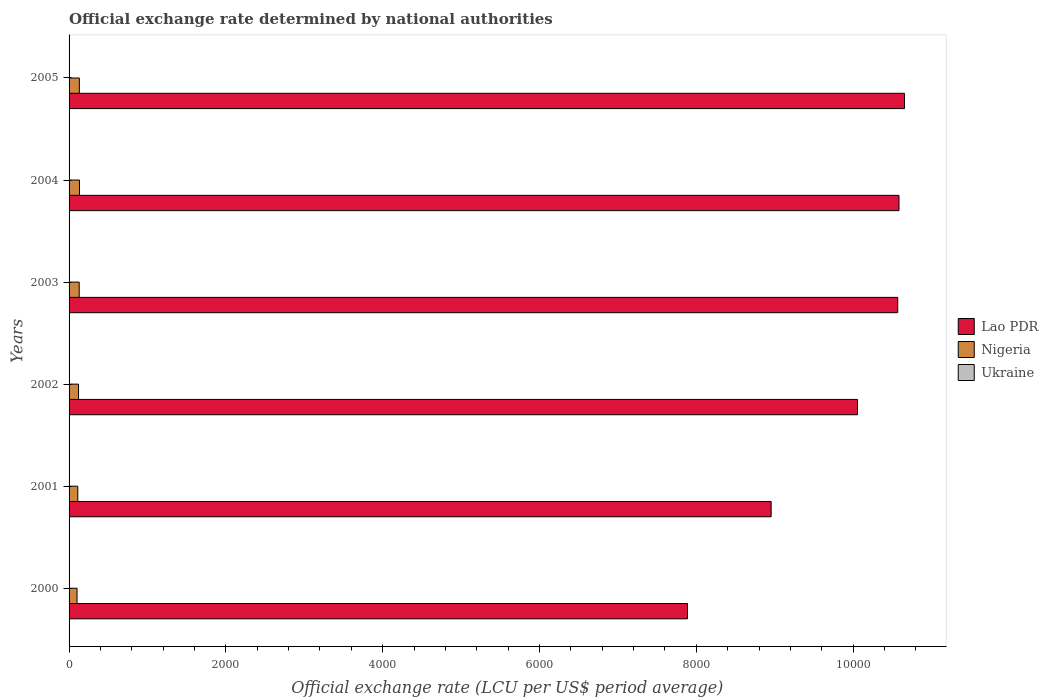How many different coloured bars are there?
Provide a succinct answer. 3. How many groups of bars are there?
Provide a short and direct response. 6. In how many cases, is the number of bars for a given year not equal to the number of legend labels?
Offer a very short reply. 0. What is the official exchange rate in Nigeria in 2001?
Your response must be concise. 111.23. Across all years, what is the maximum official exchange rate in Nigeria?
Offer a terse response. 132.89. Across all years, what is the minimum official exchange rate in Lao PDR?
Give a very brief answer. 7887.64. In which year was the official exchange rate in Lao PDR minimum?
Make the answer very short. 2000. What is the total official exchange rate in Lao PDR in the graph?
Provide a short and direct response. 5.87e+04. What is the difference between the official exchange rate in Lao PDR in 2001 and that in 2003?
Make the answer very short. -1614.45. What is the difference between the official exchange rate in Lao PDR in 2000 and the official exchange rate in Nigeria in 2001?
Offer a terse response. 7776.41. What is the average official exchange rate in Nigeria per year?
Offer a very short reply. 121.15. In the year 2004, what is the difference between the official exchange rate in Nigeria and official exchange rate in Ukraine?
Provide a short and direct response. 127.57. In how many years, is the official exchange rate in Lao PDR greater than 2800 LCU?
Ensure brevity in your answer.  6. What is the ratio of the official exchange rate in Nigeria in 2001 to that in 2003?
Ensure brevity in your answer.  0.86. Is the official exchange rate in Lao PDR in 2000 less than that in 2005?
Your answer should be compact. Yes. What is the difference between the highest and the second highest official exchange rate in Ukraine?
Keep it short and to the point. 0.07. What is the difference between the highest and the lowest official exchange rate in Nigeria?
Offer a very short reply. 31.19. In how many years, is the official exchange rate in Ukraine greater than the average official exchange rate in Ukraine taken over all years?
Provide a short and direct response. 4. What does the 2nd bar from the top in 2001 represents?
Keep it short and to the point. Nigeria. What does the 3rd bar from the bottom in 2000 represents?
Your response must be concise. Ukraine. Is it the case that in every year, the sum of the official exchange rate in Ukraine and official exchange rate in Nigeria is greater than the official exchange rate in Lao PDR?
Keep it short and to the point. No. What is the difference between two consecutive major ticks on the X-axis?
Your answer should be very brief. 2000. Where does the legend appear in the graph?
Make the answer very short. Center right. How many legend labels are there?
Keep it short and to the point. 3. What is the title of the graph?
Provide a short and direct response. Official exchange rate determined by national authorities. What is the label or title of the X-axis?
Your response must be concise. Official exchange rate (LCU per US$ period average). What is the label or title of the Y-axis?
Keep it short and to the point. Years. What is the Official exchange rate (LCU per US$ period average) of Lao PDR in 2000?
Your answer should be very brief. 7887.64. What is the Official exchange rate (LCU per US$ period average) of Nigeria in 2000?
Keep it short and to the point. 101.7. What is the Official exchange rate (LCU per US$ period average) of Ukraine in 2000?
Provide a short and direct response. 5.44. What is the Official exchange rate (LCU per US$ period average) of Lao PDR in 2001?
Keep it short and to the point. 8954.58. What is the Official exchange rate (LCU per US$ period average) of Nigeria in 2001?
Offer a very short reply. 111.23. What is the Official exchange rate (LCU per US$ period average) of Ukraine in 2001?
Provide a succinct answer. 5.37. What is the Official exchange rate (LCU per US$ period average) of Lao PDR in 2002?
Make the answer very short. 1.01e+04. What is the Official exchange rate (LCU per US$ period average) of Nigeria in 2002?
Offer a terse response. 120.58. What is the Official exchange rate (LCU per US$ period average) in Ukraine in 2002?
Provide a succinct answer. 5.33. What is the Official exchange rate (LCU per US$ period average) of Lao PDR in 2003?
Your answer should be compact. 1.06e+04. What is the Official exchange rate (LCU per US$ period average) in Nigeria in 2003?
Provide a short and direct response. 129.22. What is the Official exchange rate (LCU per US$ period average) of Ukraine in 2003?
Offer a terse response. 5.33. What is the Official exchange rate (LCU per US$ period average) in Lao PDR in 2004?
Keep it short and to the point. 1.06e+04. What is the Official exchange rate (LCU per US$ period average) of Nigeria in 2004?
Give a very brief answer. 132.89. What is the Official exchange rate (LCU per US$ period average) of Ukraine in 2004?
Provide a short and direct response. 5.32. What is the Official exchange rate (LCU per US$ period average) of Lao PDR in 2005?
Your answer should be compact. 1.07e+04. What is the Official exchange rate (LCU per US$ period average) in Nigeria in 2005?
Ensure brevity in your answer.  131.27. What is the Official exchange rate (LCU per US$ period average) of Ukraine in 2005?
Your answer should be compact. 5.12. Across all years, what is the maximum Official exchange rate (LCU per US$ period average) of Lao PDR?
Your response must be concise. 1.07e+04. Across all years, what is the maximum Official exchange rate (LCU per US$ period average) of Nigeria?
Provide a short and direct response. 132.89. Across all years, what is the maximum Official exchange rate (LCU per US$ period average) of Ukraine?
Offer a very short reply. 5.44. Across all years, what is the minimum Official exchange rate (LCU per US$ period average) in Lao PDR?
Offer a very short reply. 7887.64. Across all years, what is the minimum Official exchange rate (LCU per US$ period average) in Nigeria?
Provide a succinct answer. 101.7. Across all years, what is the minimum Official exchange rate (LCU per US$ period average) in Ukraine?
Ensure brevity in your answer.  5.12. What is the total Official exchange rate (LCU per US$ period average) in Lao PDR in the graph?
Give a very brief answer. 5.87e+04. What is the total Official exchange rate (LCU per US$ period average) in Nigeria in the graph?
Your answer should be very brief. 726.89. What is the total Official exchange rate (LCU per US$ period average) in Ukraine in the graph?
Ensure brevity in your answer.  31.92. What is the difference between the Official exchange rate (LCU per US$ period average) of Lao PDR in 2000 and that in 2001?
Give a very brief answer. -1066.94. What is the difference between the Official exchange rate (LCU per US$ period average) of Nigeria in 2000 and that in 2001?
Offer a very short reply. -9.53. What is the difference between the Official exchange rate (LCU per US$ period average) in Ukraine in 2000 and that in 2001?
Offer a very short reply. 0.07. What is the difference between the Official exchange rate (LCU per US$ period average) of Lao PDR in 2000 and that in 2002?
Offer a very short reply. -2168.69. What is the difference between the Official exchange rate (LCU per US$ period average) in Nigeria in 2000 and that in 2002?
Your answer should be very brief. -18.88. What is the difference between the Official exchange rate (LCU per US$ period average) of Ukraine in 2000 and that in 2002?
Your answer should be compact. 0.11. What is the difference between the Official exchange rate (LCU per US$ period average) of Lao PDR in 2000 and that in 2003?
Make the answer very short. -2681.39. What is the difference between the Official exchange rate (LCU per US$ period average) in Nigeria in 2000 and that in 2003?
Give a very brief answer. -27.52. What is the difference between the Official exchange rate (LCU per US$ period average) in Ukraine in 2000 and that in 2003?
Make the answer very short. 0.11. What is the difference between the Official exchange rate (LCU per US$ period average) of Lao PDR in 2000 and that in 2004?
Make the answer very short. -2697.73. What is the difference between the Official exchange rate (LCU per US$ period average) of Nigeria in 2000 and that in 2004?
Your answer should be very brief. -31.19. What is the difference between the Official exchange rate (LCU per US$ period average) of Ukraine in 2000 and that in 2004?
Offer a terse response. 0.12. What is the difference between the Official exchange rate (LCU per US$ period average) in Lao PDR in 2000 and that in 2005?
Offer a very short reply. -2767.52. What is the difference between the Official exchange rate (LCU per US$ period average) of Nigeria in 2000 and that in 2005?
Your answer should be very brief. -29.58. What is the difference between the Official exchange rate (LCU per US$ period average) in Ukraine in 2000 and that in 2005?
Provide a succinct answer. 0.32. What is the difference between the Official exchange rate (LCU per US$ period average) in Lao PDR in 2001 and that in 2002?
Provide a succinct answer. -1101.75. What is the difference between the Official exchange rate (LCU per US$ period average) in Nigeria in 2001 and that in 2002?
Offer a terse response. -9.35. What is the difference between the Official exchange rate (LCU per US$ period average) in Ukraine in 2001 and that in 2002?
Your answer should be very brief. 0.05. What is the difference between the Official exchange rate (LCU per US$ period average) of Lao PDR in 2001 and that in 2003?
Give a very brief answer. -1614.45. What is the difference between the Official exchange rate (LCU per US$ period average) in Nigeria in 2001 and that in 2003?
Ensure brevity in your answer.  -17.99. What is the difference between the Official exchange rate (LCU per US$ period average) in Ukraine in 2001 and that in 2003?
Your response must be concise. 0.04. What is the difference between the Official exchange rate (LCU per US$ period average) in Lao PDR in 2001 and that in 2004?
Give a very brief answer. -1630.79. What is the difference between the Official exchange rate (LCU per US$ period average) in Nigeria in 2001 and that in 2004?
Ensure brevity in your answer.  -21.66. What is the difference between the Official exchange rate (LCU per US$ period average) in Ukraine in 2001 and that in 2004?
Your answer should be compact. 0.05. What is the difference between the Official exchange rate (LCU per US$ period average) in Lao PDR in 2001 and that in 2005?
Provide a succinct answer. -1700.58. What is the difference between the Official exchange rate (LCU per US$ period average) in Nigeria in 2001 and that in 2005?
Offer a terse response. -20.04. What is the difference between the Official exchange rate (LCU per US$ period average) of Ukraine in 2001 and that in 2005?
Give a very brief answer. 0.25. What is the difference between the Official exchange rate (LCU per US$ period average) in Lao PDR in 2002 and that in 2003?
Keep it short and to the point. -512.7. What is the difference between the Official exchange rate (LCU per US$ period average) of Nigeria in 2002 and that in 2003?
Provide a short and direct response. -8.64. What is the difference between the Official exchange rate (LCU per US$ period average) of Ukraine in 2002 and that in 2003?
Offer a very short reply. -0.01. What is the difference between the Official exchange rate (LCU per US$ period average) in Lao PDR in 2002 and that in 2004?
Your answer should be very brief. -529.04. What is the difference between the Official exchange rate (LCU per US$ period average) in Nigeria in 2002 and that in 2004?
Ensure brevity in your answer.  -12.31. What is the difference between the Official exchange rate (LCU per US$ period average) of Ukraine in 2002 and that in 2004?
Make the answer very short. 0.01. What is the difference between the Official exchange rate (LCU per US$ period average) in Lao PDR in 2002 and that in 2005?
Offer a terse response. -598.83. What is the difference between the Official exchange rate (LCU per US$ period average) in Nigeria in 2002 and that in 2005?
Give a very brief answer. -10.7. What is the difference between the Official exchange rate (LCU per US$ period average) of Ukraine in 2002 and that in 2005?
Offer a very short reply. 0.2. What is the difference between the Official exchange rate (LCU per US$ period average) of Lao PDR in 2003 and that in 2004?
Your answer should be very brief. -16.34. What is the difference between the Official exchange rate (LCU per US$ period average) of Nigeria in 2003 and that in 2004?
Your answer should be compact. -3.67. What is the difference between the Official exchange rate (LCU per US$ period average) of Ukraine in 2003 and that in 2004?
Your response must be concise. 0.01. What is the difference between the Official exchange rate (LCU per US$ period average) in Lao PDR in 2003 and that in 2005?
Ensure brevity in your answer.  -86.13. What is the difference between the Official exchange rate (LCU per US$ period average) of Nigeria in 2003 and that in 2005?
Keep it short and to the point. -2.05. What is the difference between the Official exchange rate (LCU per US$ period average) in Ukraine in 2003 and that in 2005?
Provide a succinct answer. 0.21. What is the difference between the Official exchange rate (LCU per US$ period average) of Lao PDR in 2004 and that in 2005?
Your answer should be very brief. -69.79. What is the difference between the Official exchange rate (LCU per US$ period average) in Nigeria in 2004 and that in 2005?
Keep it short and to the point. 1.61. What is the difference between the Official exchange rate (LCU per US$ period average) in Ukraine in 2004 and that in 2005?
Provide a short and direct response. 0.19. What is the difference between the Official exchange rate (LCU per US$ period average) in Lao PDR in 2000 and the Official exchange rate (LCU per US$ period average) in Nigeria in 2001?
Your answer should be compact. 7776.41. What is the difference between the Official exchange rate (LCU per US$ period average) in Lao PDR in 2000 and the Official exchange rate (LCU per US$ period average) in Ukraine in 2001?
Provide a succinct answer. 7882.27. What is the difference between the Official exchange rate (LCU per US$ period average) of Nigeria in 2000 and the Official exchange rate (LCU per US$ period average) of Ukraine in 2001?
Offer a very short reply. 96.33. What is the difference between the Official exchange rate (LCU per US$ period average) of Lao PDR in 2000 and the Official exchange rate (LCU per US$ period average) of Nigeria in 2002?
Provide a succinct answer. 7767.07. What is the difference between the Official exchange rate (LCU per US$ period average) of Lao PDR in 2000 and the Official exchange rate (LCU per US$ period average) of Ukraine in 2002?
Keep it short and to the point. 7882.32. What is the difference between the Official exchange rate (LCU per US$ period average) in Nigeria in 2000 and the Official exchange rate (LCU per US$ period average) in Ukraine in 2002?
Offer a terse response. 96.37. What is the difference between the Official exchange rate (LCU per US$ period average) of Lao PDR in 2000 and the Official exchange rate (LCU per US$ period average) of Nigeria in 2003?
Ensure brevity in your answer.  7758.42. What is the difference between the Official exchange rate (LCU per US$ period average) in Lao PDR in 2000 and the Official exchange rate (LCU per US$ period average) in Ukraine in 2003?
Make the answer very short. 7882.31. What is the difference between the Official exchange rate (LCU per US$ period average) of Nigeria in 2000 and the Official exchange rate (LCU per US$ period average) of Ukraine in 2003?
Your answer should be very brief. 96.36. What is the difference between the Official exchange rate (LCU per US$ period average) in Lao PDR in 2000 and the Official exchange rate (LCU per US$ period average) in Nigeria in 2004?
Ensure brevity in your answer.  7754.76. What is the difference between the Official exchange rate (LCU per US$ period average) in Lao PDR in 2000 and the Official exchange rate (LCU per US$ period average) in Ukraine in 2004?
Keep it short and to the point. 7882.32. What is the difference between the Official exchange rate (LCU per US$ period average) of Nigeria in 2000 and the Official exchange rate (LCU per US$ period average) of Ukraine in 2004?
Keep it short and to the point. 96.38. What is the difference between the Official exchange rate (LCU per US$ period average) of Lao PDR in 2000 and the Official exchange rate (LCU per US$ period average) of Nigeria in 2005?
Your answer should be compact. 7756.37. What is the difference between the Official exchange rate (LCU per US$ period average) in Lao PDR in 2000 and the Official exchange rate (LCU per US$ period average) in Ukraine in 2005?
Your response must be concise. 7882.52. What is the difference between the Official exchange rate (LCU per US$ period average) in Nigeria in 2000 and the Official exchange rate (LCU per US$ period average) in Ukraine in 2005?
Your response must be concise. 96.57. What is the difference between the Official exchange rate (LCU per US$ period average) of Lao PDR in 2001 and the Official exchange rate (LCU per US$ period average) of Nigeria in 2002?
Your response must be concise. 8834.01. What is the difference between the Official exchange rate (LCU per US$ period average) of Lao PDR in 2001 and the Official exchange rate (LCU per US$ period average) of Ukraine in 2002?
Offer a very short reply. 8949.26. What is the difference between the Official exchange rate (LCU per US$ period average) in Nigeria in 2001 and the Official exchange rate (LCU per US$ period average) in Ukraine in 2002?
Make the answer very short. 105.9. What is the difference between the Official exchange rate (LCU per US$ period average) in Lao PDR in 2001 and the Official exchange rate (LCU per US$ period average) in Nigeria in 2003?
Offer a very short reply. 8825.36. What is the difference between the Official exchange rate (LCU per US$ period average) of Lao PDR in 2001 and the Official exchange rate (LCU per US$ period average) of Ukraine in 2003?
Keep it short and to the point. 8949.25. What is the difference between the Official exchange rate (LCU per US$ period average) in Nigeria in 2001 and the Official exchange rate (LCU per US$ period average) in Ukraine in 2003?
Offer a very short reply. 105.9. What is the difference between the Official exchange rate (LCU per US$ period average) in Lao PDR in 2001 and the Official exchange rate (LCU per US$ period average) in Nigeria in 2004?
Your answer should be very brief. 8821.7. What is the difference between the Official exchange rate (LCU per US$ period average) in Lao PDR in 2001 and the Official exchange rate (LCU per US$ period average) in Ukraine in 2004?
Your response must be concise. 8949.26. What is the difference between the Official exchange rate (LCU per US$ period average) in Nigeria in 2001 and the Official exchange rate (LCU per US$ period average) in Ukraine in 2004?
Ensure brevity in your answer.  105.91. What is the difference between the Official exchange rate (LCU per US$ period average) of Lao PDR in 2001 and the Official exchange rate (LCU per US$ period average) of Nigeria in 2005?
Ensure brevity in your answer.  8823.31. What is the difference between the Official exchange rate (LCU per US$ period average) in Lao PDR in 2001 and the Official exchange rate (LCU per US$ period average) in Ukraine in 2005?
Provide a short and direct response. 8949.46. What is the difference between the Official exchange rate (LCU per US$ period average) in Nigeria in 2001 and the Official exchange rate (LCU per US$ period average) in Ukraine in 2005?
Keep it short and to the point. 106.11. What is the difference between the Official exchange rate (LCU per US$ period average) of Lao PDR in 2002 and the Official exchange rate (LCU per US$ period average) of Nigeria in 2003?
Ensure brevity in your answer.  9927.11. What is the difference between the Official exchange rate (LCU per US$ period average) of Lao PDR in 2002 and the Official exchange rate (LCU per US$ period average) of Ukraine in 2003?
Keep it short and to the point. 1.01e+04. What is the difference between the Official exchange rate (LCU per US$ period average) in Nigeria in 2002 and the Official exchange rate (LCU per US$ period average) in Ukraine in 2003?
Give a very brief answer. 115.25. What is the difference between the Official exchange rate (LCU per US$ period average) in Lao PDR in 2002 and the Official exchange rate (LCU per US$ period average) in Nigeria in 2004?
Offer a very short reply. 9923.45. What is the difference between the Official exchange rate (LCU per US$ period average) of Lao PDR in 2002 and the Official exchange rate (LCU per US$ period average) of Ukraine in 2004?
Give a very brief answer. 1.01e+04. What is the difference between the Official exchange rate (LCU per US$ period average) in Nigeria in 2002 and the Official exchange rate (LCU per US$ period average) in Ukraine in 2004?
Offer a very short reply. 115.26. What is the difference between the Official exchange rate (LCU per US$ period average) of Lao PDR in 2002 and the Official exchange rate (LCU per US$ period average) of Nigeria in 2005?
Your response must be concise. 9925.06. What is the difference between the Official exchange rate (LCU per US$ period average) of Lao PDR in 2002 and the Official exchange rate (LCU per US$ period average) of Ukraine in 2005?
Make the answer very short. 1.01e+04. What is the difference between the Official exchange rate (LCU per US$ period average) in Nigeria in 2002 and the Official exchange rate (LCU per US$ period average) in Ukraine in 2005?
Give a very brief answer. 115.45. What is the difference between the Official exchange rate (LCU per US$ period average) in Lao PDR in 2003 and the Official exchange rate (LCU per US$ period average) in Nigeria in 2004?
Keep it short and to the point. 1.04e+04. What is the difference between the Official exchange rate (LCU per US$ period average) of Lao PDR in 2003 and the Official exchange rate (LCU per US$ period average) of Ukraine in 2004?
Your response must be concise. 1.06e+04. What is the difference between the Official exchange rate (LCU per US$ period average) in Nigeria in 2003 and the Official exchange rate (LCU per US$ period average) in Ukraine in 2004?
Provide a short and direct response. 123.9. What is the difference between the Official exchange rate (LCU per US$ period average) of Lao PDR in 2003 and the Official exchange rate (LCU per US$ period average) of Nigeria in 2005?
Provide a short and direct response. 1.04e+04. What is the difference between the Official exchange rate (LCU per US$ period average) of Lao PDR in 2003 and the Official exchange rate (LCU per US$ period average) of Ukraine in 2005?
Your answer should be very brief. 1.06e+04. What is the difference between the Official exchange rate (LCU per US$ period average) in Nigeria in 2003 and the Official exchange rate (LCU per US$ period average) in Ukraine in 2005?
Keep it short and to the point. 124.1. What is the difference between the Official exchange rate (LCU per US$ period average) of Lao PDR in 2004 and the Official exchange rate (LCU per US$ period average) of Nigeria in 2005?
Keep it short and to the point. 1.05e+04. What is the difference between the Official exchange rate (LCU per US$ period average) of Lao PDR in 2004 and the Official exchange rate (LCU per US$ period average) of Ukraine in 2005?
Keep it short and to the point. 1.06e+04. What is the difference between the Official exchange rate (LCU per US$ period average) in Nigeria in 2004 and the Official exchange rate (LCU per US$ period average) in Ukraine in 2005?
Offer a terse response. 127.76. What is the average Official exchange rate (LCU per US$ period average) in Lao PDR per year?
Provide a succinct answer. 9784.69. What is the average Official exchange rate (LCU per US$ period average) of Nigeria per year?
Offer a very short reply. 121.15. What is the average Official exchange rate (LCU per US$ period average) of Ukraine per year?
Give a very brief answer. 5.32. In the year 2000, what is the difference between the Official exchange rate (LCU per US$ period average) in Lao PDR and Official exchange rate (LCU per US$ period average) in Nigeria?
Ensure brevity in your answer.  7785.95. In the year 2000, what is the difference between the Official exchange rate (LCU per US$ period average) in Lao PDR and Official exchange rate (LCU per US$ period average) in Ukraine?
Provide a succinct answer. 7882.2. In the year 2000, what is the difference between the Official exchange rate (LCU per US$ period average) in Nigeria and Official exchange rate (LCU per US$ period average) in Ukraine?
Offer a very short reply. 96.26. In the year 2001, what is the difference between the Official exchange rate (LCU per US$ period average) in Lao PDR and Official exchange rate (LCU per US$ period average) in Nigeria?
Make the answer very short. 8843.35. In the year 2001, what is the difference between the Official exchange rate (LCU per US$ period average) in Lao PDR and Official exchange rate (LCU per US$ period average) in Ukraine?
Give a very brief answer. 8949.21. In the year 2001, what is the difference between the Official exchange rate (LCU per US$ period average) in Nigeria and Official exchange rate (LCU per US$ period average) in Ukraine?
Your response must be concise. 105.86. In the year 2002, what is the difference between the Official exchange rate (LCU per US$ period average) in Lao PDR and Official exchange rate (LCU per US$ period average) in Nigeria?
Give a very brief answer. 9935.76. In the year 2002, what is the difference between the Official exchange rate (LCU per US$ period average) in Lao PDR and Official exchange rate (LCU per US$ period average) in Ukraine?
Provide a short and direct response. 1.01e+04. In the year 2002, what is the difference between the Official exchange rate (LCU per US$ period average) in Nigeria and Official exchange rate (LCU per US$ period average) in Ukraine?
Provide a succinct answer. 115.25. In the year 2003, what is the difference between the Official exchange rate (LCU per US$ period average) of Lao PDR and Official exchange rate (LCU per US$ period average) of Nigeria?
Your response must be concise. 1.04e+04. In the year 2003, what is the difference between the Official exchange rate (LCU per US$ period average) in Lao PDR and Official exchange rate (LCU per US$ period average) in Ukraine?
Make the answer very short. 1.06e+04. In the year 2003, what is the difference between the Official exchange rate (LCU per US$ period average) in Nigeria and Official exchange rate (LCU per US$ period average) in Ukraine?
Your answer should be very brief. 123.89. In the year 2004, what is the difference between the Official exchange rate (LCU per US$ period average) of Lao PDR and Official exchange rate (LCU per US$ period average) of Nigeria?
Your answer should be compact. 1.05e+04. In the year 2004, what is the difference between the Official exchange rate (LCU per US$ period average) in Lao PDR and Official exchange rate (LCU per US$ period average) in Ukraine?
Provide a short and direct response. 1.06e+04. In the year 2004, what is the difference between the Official exchange rate (LCU per US$ period average) of Nigeria and Official exchange rate (LCU per US$ period average) of Ukraine?
Offer a very short reply. 127.57. In the year 2005, what is the difference between the Official exchange rate (LCU per US$ period average) in Lao PDR and Official exchange rate (LCU per US$ period average) in Nigeria?
Provide a short and direct response. 1.05e+04. In the year 2005, what is the difference between the Official exchange rate (LCU per US$ period average) in Lao PDR and Official exchange rate (LCU per US$ period average) in Ukraine?
Your response must be concise. 1.07e+04. In the year 2005, what is the difference between the Official exchange rate (LCU per US$ period average) in Nigeria and Official exchange rate (LCU per US$ period average) in Ukraine?
Ensure brevity in your answer.  126.15. What is the ratio of the Official exchange rate (LCU per US$ period average) of Lao PDR in 2000 to that in 2001?
Provide a short and direct response. 0.88. What is the ratio of the Official exchange rate (LCU per US$ period average) in Nigeria in 2000 to that in 2001?
Provide a succinct answer. 0.91. What is the ratio of the Official exchange rate (LCU per US$ period average) in Ukraine in 2000 to that in 2001?
Your response must be concise. 1.01. What is the ratio of the Official exchange rate (LCU per US$ period average) in Lao PDR in 2000 to that in 2002?
Make the answer very short. 0.78. What is the ratio of the Official exchange rate (LCU per US$ period average) in Nigeria in 2000 to that in 2002?
Offer a terse response. 0.84. What is the ratio of the Official exchange rate (LCU per US$ period average) in Ukraine in 2000 to that in 2002?
Your answer should be compact. 1.02. What is the ratio of the Official exchange rate (LCU per US$ period average) in Lao PDR in 2000 to that in 2003?
Make the answer very short. 0.75. What is the ratio of the Official exchange rate (LCU per US$ period average) of Nigeria in 2000 to that in 2003?
Provide a short and direct response. 0.79. What is the ratio of the Official exchange rate (LCU per US$ period average) in Ukraine in 2000 to that in 2003?
Make the answer very short. 1.02. What is the ratio of the Official exchange rate (LCU per US$ period average) in Lao PDR in 2000 to that in 2004?
Make the answer very short. 0.75. What is the ratio of the Official exchange rate (LCU per US$ period average) of Nigeria in 2000 to that in 2004?
Your answer should be compact. 0.77. What is the ratio of the Official exchange rate (LCU per US$ period average) in Ukraine in 2000 to that in 2004?
Provide a short and direct response. 1.02. What is the ratio of the Official exchange rate (LCU per US$ period average) in Lao PDR in 2000 to that in 2005?
Offer a terse response. 0.74. What is the ratio of the Official exchange rate (LCU per US$ period average) of Nigeria in 2000 to that in 2005?
Make the answer very short. 0.77. What is the ratio of the Official exchange rate (LCU per US$ period average) of Ukraine in 2000 to that in 2005?
Give a very brief answer. 1.06. What is the ratio of the Official exchange rate (LCU per US$ period average) of Lao PDR in 2001 to that in 2002?
Your answer should be very brief. 0.89. What is the ratio of the Official exchange rate (LCU per US$ period average) of Nigeria in 2001 to that in 2002?
Your answer should be compact. 0.92. What is the ratio of the Official exchange rate (LCU per US$ period average) in Ukraine in 2001 to that in 2002?
Offer a terse response. 1.01. What is the ratio of the Official exchange rate (LCU per US$ period average) in Lao PDR in 2001 to that in 2003?
Provide a short and direct response. 0.85. What is the ratio of the Official exchange rate (LCU per US$ period average) of Nigeria in 2001 to that in 2003?
Offer a terse response. 0.86. What is the ratio of the Official exchange rate (LCU per US$ period average) in Ukraine in 2001 to that in 2003?
Your response must be concise. 1.01. What is the ratio of the Official exchange rate (LCU per US$ period average) in Lao PDR in 2001 to that in 2004?
Make the answer very short. 0.85. What is the ratio of the Official exchange rate (LCU per US$ period average) of Nigeria in 2001 to that in 2004?
Your response must be concise. 0.84. What is the ratio of the Official exchange rate (LCU per US$ period average) of Ukraine in 2001 to that in 2004?
Keep it short and to the point. 1.01. What is the ratio of the Official exchange rate (LCU per US$ period average) of Lao PDR in 2001 to that in 2005?
Offer a terse response. 0.84. What is the ratio of the Official exchange rate (LCU per US$ period average) in Nigeria in 2001 to that in 2005?
Provide a succinct answer. 0.85. What is the ratio of the Official exchange rate (LCU per US$ period average) in Ukraine in 2001 to that in 2005?
Your answer should be very brief. 1.05. What is the ratio of the Official exchange rate (LCU per US$ period average) of Lao PDR in 2002 to that in 2003?
Give a very brief answer. 0.95. What is the ratio of the Official exchange rate (LCU per US$ period average) in Nigeria in 2002 to that in 2003?
Make the answer very short. 0.93. What is the ratio of the Official exchange rate (LCU per US$ period average) of Nigeria in 2002 to that in 2004?
Give a very brief answer. 0.91. What is the ratio of the Official exchange rate (LCU per US$ period average) of Lao PDR in 2002 to that in 2005?
Make the answer very short. 0.94. What is the ratio of the Official exchange rate (LCU per US$ period average) of Nigeria in 2002 to that in 2005?
Offer a very short reply. 0.92. What is the ratio of the Official exchange rate (LCU per US$ period average) of Ukraine in 2002 to that in 2005?
Offer a very short reply. 1.04. What is the ratio of the Official exchange rate (LCU per US$ period average) in Lao PDR in 2003 to that in 2004?
Offer a very short reply. 1. What is the ratio of the Official exchange rate (LCU per US$ period average) in Nigeria in 2003 to that in 2004?
Offer a very short reply. 0.97. What is the ratio of the Official exchange rate (LCU per US$ period average) in Lao PDR in 2003 to that in 2005?
Give a very brief answer. 0.99. What is the ratio of the Official exchange rate (LCU per US$ period average) in Nigeria in 2003 to that in 2005?
Your answer should be compact. 0.98. What is the ratio of the Official exchange rate (LCU per US$ period average) in Ukraine in 2003 to that in 2005?
Offer a very short reply. 1.04. What is the ratio of the Official exchange rate (LCU per US$ period average) in Nigeria in 2004 to that in 2005?
Keep it short and to the point. 1.01. What is the ratio of the Official exchange rate (LCU per US$ period average) of Ukraine in 2004 to that in 2005?
Provide a succinct answer. 1.04. What is the difference between the highest and the second highest Official exchange rate (LCU per US$ period average) in Lao PDR?
Ensure brevity in your answer.  69.79. What is the difference between the highest and the second highest Official exchange rate (LCU per US$ period average) of Nigeria?
Your response must be concise. 1.61. What is the difference between the highest and the second highest Official exchange rate (LCU per US$ period average) of Ukraine?
Offer a very short reply. 0.07. What is the difference between the highest and the lowest Official exchange rate (LCU per US$ period average) in Lao PDR?
Make the answer very short. 2767.52. What is the difference between the highest and the lowest Official exchange rate (LCU per US$ period average) in Nigeria?
Ensure brevity in your answer.  31.19. What is the difference between the highest and the lowest Official exchange rate (LCU per US$ period average) in Ukraine?
Your response must be concise. 0.32. 